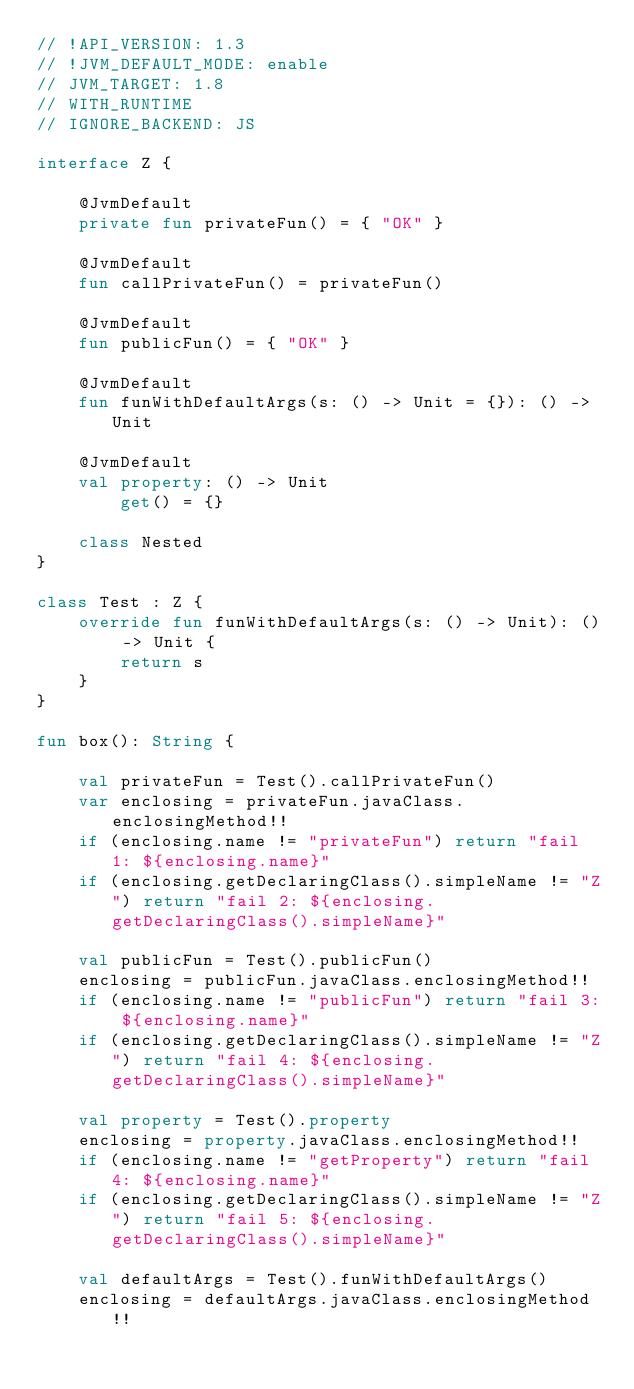<code> <loc_0><loc_0><loc_500><loc_500><_Kotlin_>// !API_VERSION: 1.3
// !JVM_DEFAULT_MODE: enable
// JVM_TARGET: 1.8
// WITH_RUNTIME
// IGNORE_BACKEND: JS

interface Z {

    @JvmDefault
    private fun privateFun() = { "OK" }

    @JvmDefault
    fun callPrivateFun() = privateFun()

    @JvmDefault
    fun publicFun() = { "OK" }

    @JvmDefault
    fun funWithDefaultArgs(s: () -> Unit = {}): () -> Unit

    @JvmDefault
    val property: () -> Unit
        get() = {}

    class Nested
}

class Test : Z {
    override fun funWithDefaultArgs(s: () -> Unit): () -> Unit {
        return s
    }
}

fun box(): String {

    val privateFun = Test().callPrivateFun()
    var enclosing = privateFun.javaClass.enclosingMethod!!
    if (enclosing.name != "privateFun") return "fail 1: ${enclosing.name}"
    if (enclosing.getDeclaringClass().simpleName != "Z") return "fail 2: ${enclosing.getDeclaringClass().simpleName}"

    val publicFun = Test().publicFun()
    enclosing = publicFun.javaClass.enclosingMethod!!
    if (enclosing.name != "publicFun") return "fail 3: ${enclosing.name}"
    if (enclosing.getDeclaringClass().simpleName != "Z") return "fail 4: ${enclosing.getDeclaringClass().simpleName}"

    val property = Test().property
    enclosing = property.javaClass.enclosingMethod!!
    if (enclosing.name != "getProperty") return "fail 4: ${enclosing.name}"
    if (enclosing.getDeclaringClass().simpleName != "Z") return "fail 5: ${enclosing.getDeclaringClass().simpleName}"

    val defaultArgs = Test().funWithDefaultArgs()
    enclosing = defaultArgs.javaClass.enclosingMethod!!</code> 